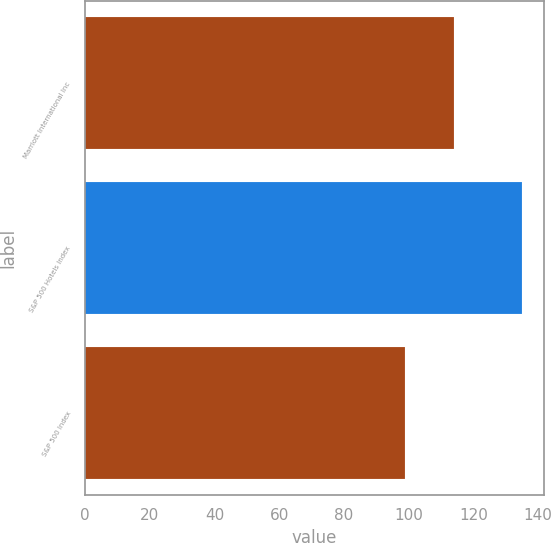Convert chart to OTSL. <chart><loc_0><loc_0><loc_500><loc_500><bar_chart><fcel>Marriott International Inc<fcel>S&P 500 Hotels Index<fcel>S&P 500 Index<nl><fcel>113.9<fcel>135.1<fcel>98.8<nl></chart> 